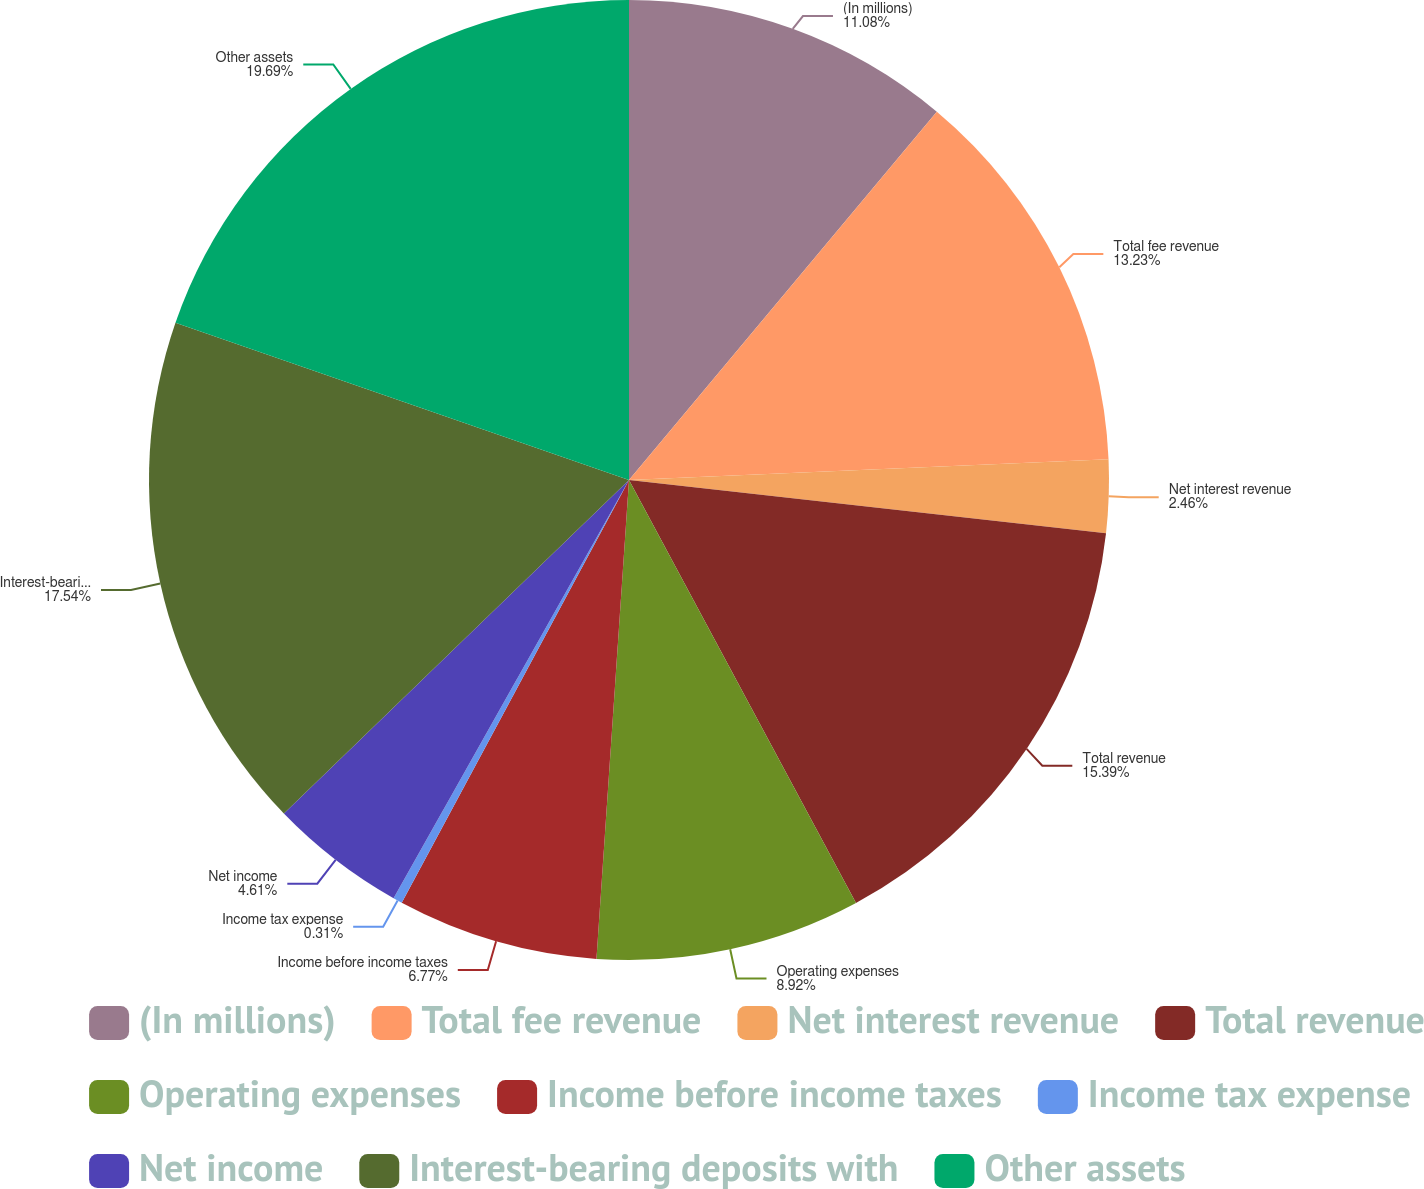<chart> <loc_0><loc_0><loc_500><loc_500><pie_chart><fcel>(In millions)<fcel>Total fee revenue<fcel>Net interest revenue<fcel>Total revenue<fcel>Operating expenses<fcel>Income before income taxes<fcel>Income tax expense<fcel>Net income<fcel>Interest-bearing deposits with<fcel>Other assets<nl><fcel>11.08%<fcel>13.23%<fcel>2.46%<fcel>15.39%<fcel>8.92%<fcel>6.77%<fcel>0.31%<fcel>4.61%<fcel>17.54%<fcel>19.69%<nl></chart> 